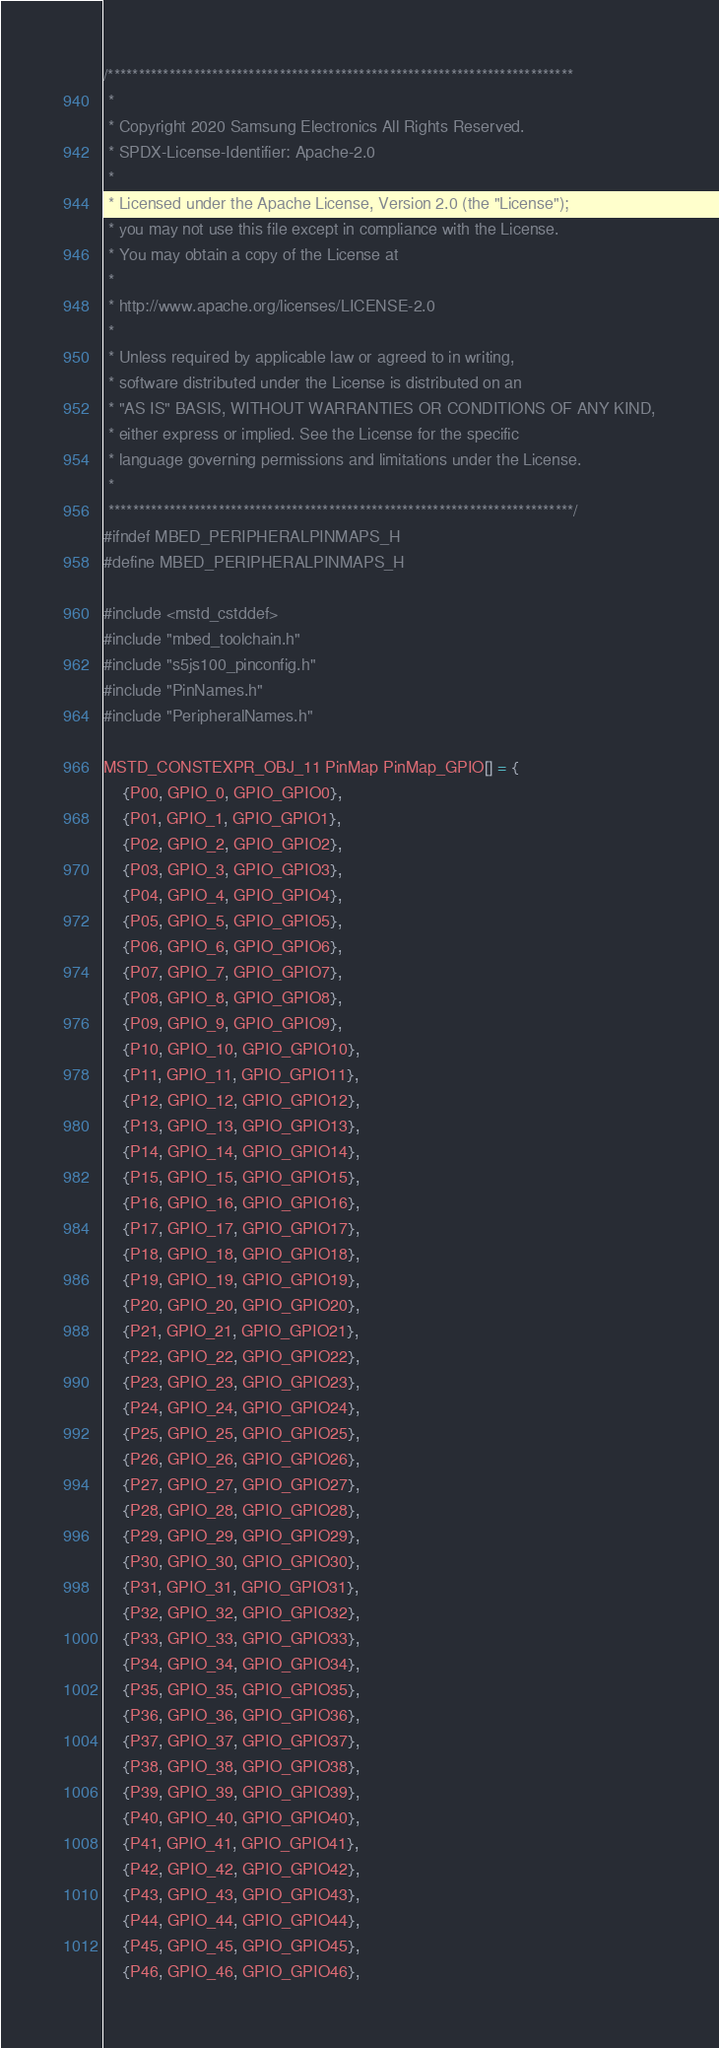Convert code to text. <code><loc_0><loc_0><loc_500><loc_500><_C_>/****************************************************************************
 *
 * Copyright 2020 Samsung Electronics All Rights Reserved.
 * SPDX-License-Identifier: Apache-2.0
 *
 * Licensed under the Apache License, Version 2.0 (the "License");
 * you may not use this file except in compliance with the License.
 * You may obtain a copy of the License at
 *
 * http://www.apache.org/licenses/LICENSE-2.0
 *
 * Unless required by applicable law or agreed to in writing,
 * software distributed under the License is distributed on an
 * "AS IS" BASIS, WITHOUT WARRANTIES OR CONDITIONS OF ANY KIND,
 * either express or implied. See the License for the specific
 * language governing permissions and limitations under the License.
 *
 ****************************************************************************/
#ifndef MBED_PERIPHERALPINMAPS_H
#define MBED_PERIPHERALPINMAPS_H

#include <mstd_cstddef>
#include "mbed_toolchain.h"
#include "s5js100_pinconfig.h"
#include "PinNames.h"
#include "PeripheralNames.h"

MSTD_CONSTEXPR_OBJ_11 PinMap PinMap_GPIO[] = {
	{P00, GPIO_0, GPIO_GPIO0},
	{P01, GPIO_1, GPIO_GPIO1},
	{P02, GPIO_2, GPIO_GPIO2},
	{P03, GPIO_3, GPIO_GPIO3},
	{P04, GPIO_4, GPIO_GPIO4},
	{P05, GPIO_5, GPIO_GPIO5},
	{P06, GPIO_6, GPIO_GPIO6},
	{P07, GPIO_7, GPIO_GPIO7},
	{P08, GPIO_8, GPIO_GPIO8},
	{P09, GPIO_9, GPIO_GPIO9},
	{P10, GPIO_10, GPIO_GPIO10},
	{P11, GPIO_11, GPIO_GPIO11},
	{P12, GPIO_12, GPIO_GPIO12},
	{P13, GPIO_13, GPIO_GPIO13},
	{P14, GPIO_14, GPIO_GPIO14},
	{P15, GPIO_15, GPIO_GPIO15},
	{P16, GPIO_16, GPIO_GPIO16},
	{P17, GPIO_17, GPIO_GPIO17},
	{P18, GPIO_18, GPIO_GPIO18},
	{P19, GPIO_19, GPIO_GPIO19},
	{P20, GPIO_20, GPIO_GPIO20},
	{P21, GPIO_21, GPIO_GPIO21},
	{P22, GPIO_22, GPIO_GPIO22},
	{P23, GPIO_23, GPIO_GPIO23},
	{P24, GPIO_24, GPIO_GPIO24},
	{P25, GPIO_25, GPIO_GPIO25},
	{P26, GPIO_26, GPIO_GPIO26},
	{P27, GPIO_27, GPIO_GPIO27},
	{P28, GPIO_28, GPIO_GPIO28},
	{P29, GPIO_29, GPIO_GPIO29},
	{P30, GPIO_30, GPIO_GPIO30},
	{P31, GPIO_31, GPIO_GPIO31},
	{P32, GPIO_32, GPIO_GPIO32},
	{P33, GPIO_33, GPIO_GPIO33},
	{P34, GPIO_34, GPIO_GPIO34},
	{P35, GPIO_35, GPIO_GPIO35},
	{P36, GPIO_36, GPIO_GPIO36},
	{P37, GPIO_37, GPIO_GPIO37},
	{P38, GPIO_38, GPIO_GPIO38},
	{P39, GPIO_39, GPIO_GPIO39},
	{P40, GPIO_40, GPIO_GPIO40},
	{P41, GPIO_41, GPIO_GPIO41},
	{P42, GPIO_42, GPIO_GPIO42},
	{P43, GPIO_43, GPIO_GPIO43},
	{P44, GPIO_44, GPIO_GPIO44},
	{P45, GPIO_45, GPIO_GPIO45},
	{P46, GPIO_46, GPIO_GPIO46},</code> 